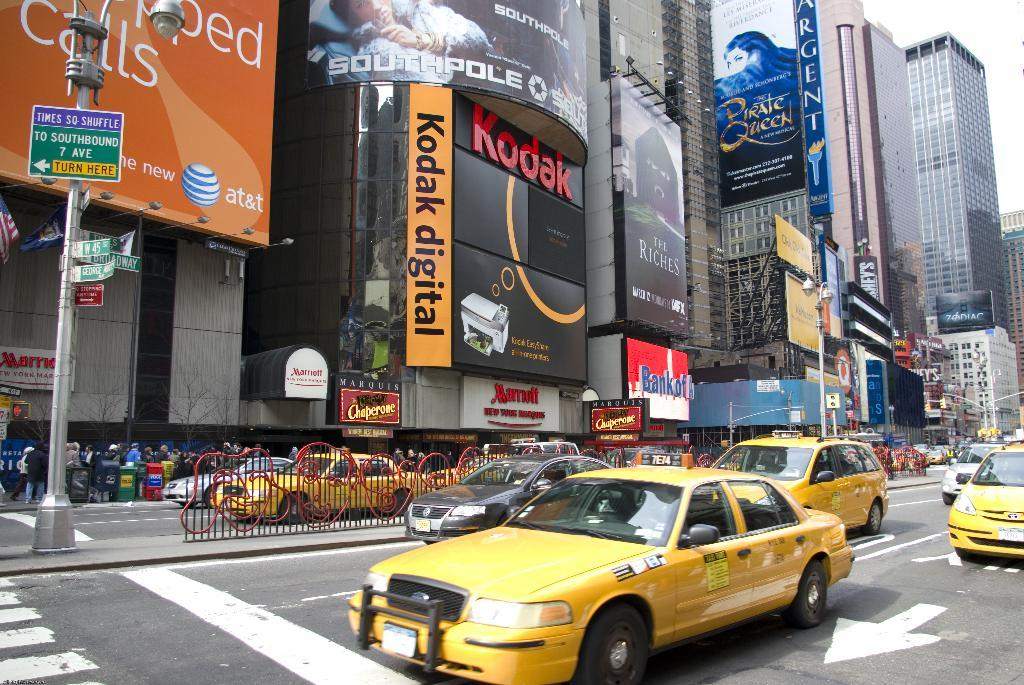Provide a one-sentence caption for the provided image. A Kodak digital sign can be seen on a building in a city. 